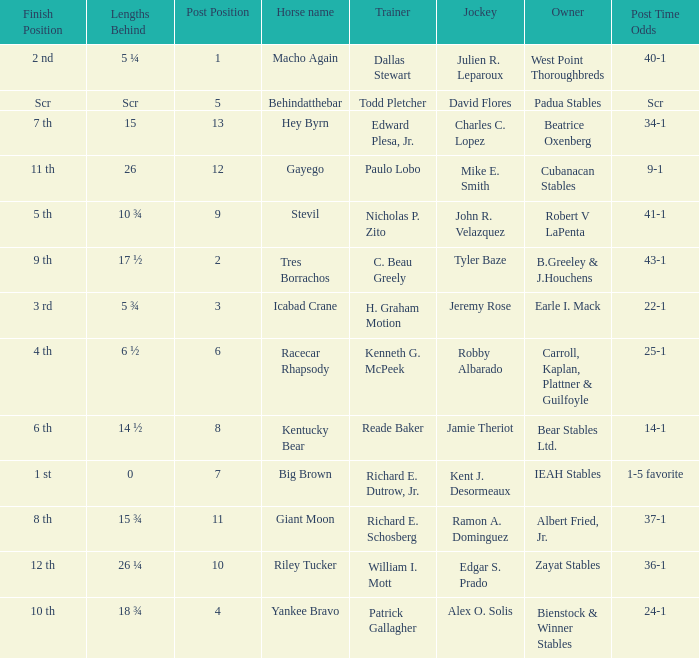What's the lengths behind of Jockey Ramon A. Dominguez? 15 ¾. 